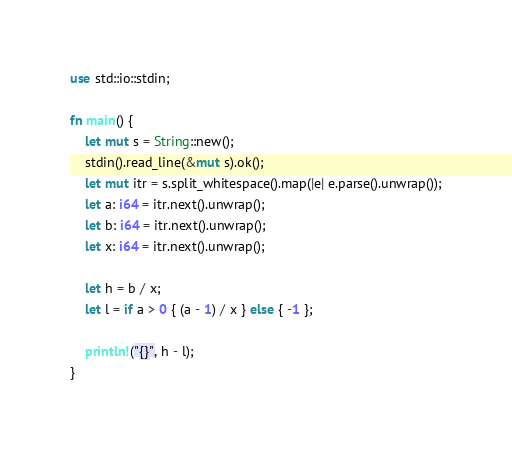<code> <loc_0><loc_0><loc_500><loc_500><_Rust_>use std::io::stdin;

fn main() {
    let mut s = String::new();
    stdin().read_line(&mut s).ok();
    let mut itr = s.split_whitespace().map(|e| e.parse().unwrap());
    let a: i64 = itr.next().unwrap();
    let b: i64 = itr.next().unwrap();
    let x: i64 = itr.next().unwrap();

    let h = b / x;
    let l = if a > 0 { (a - 1) / x } else { -1 };

    println!("{}", h - l);
}
</code> 